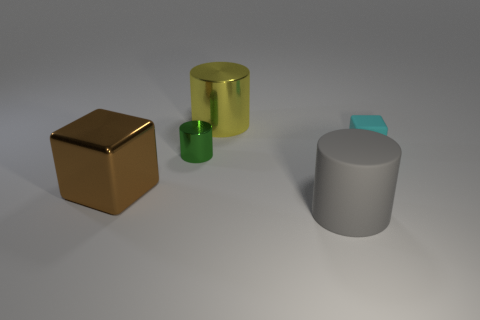How many other objects are there of the same size as the cyan block?
Your answer should be very brief. 1. What is the material of the big thing that is on the right side of the cylinder that is behind the small thing that is in front of the tiny cyan block?
Your answer should be compact. Rubber. Is the material of the gray thing the same as the large thing that is behind the brown shiny cube?
Ensure brevity in your answer.  No. Are there fewer metallic cylinders that are in front of the green thing than small cyan cubes that are behind the brown metal cube?
Provide a short and direct response. Yes. What number of other cyan blocks have the same material as the small block?
Provide a short and direct response. 0. Is there a yellow metallic thing that is in front of the big thing that is left of the shiny cylinder right of the green metallic object?
Make the answer very short. No. How many spheres are brown things or green shiny things?
Offer a terse response. 0. There is a tiny rubber thing; is it the same shape as the rubber thing in front of the cyan object?
Keep it short and to the point. No. Are there fewer rubber blocks on the left side of the large metallic cylinder than big gray matte cylinders?
Your answer should be very brief. Yes. There is a tiny green object; are there any matte cylinders in front of it?
Offer a terse response. Yes. 